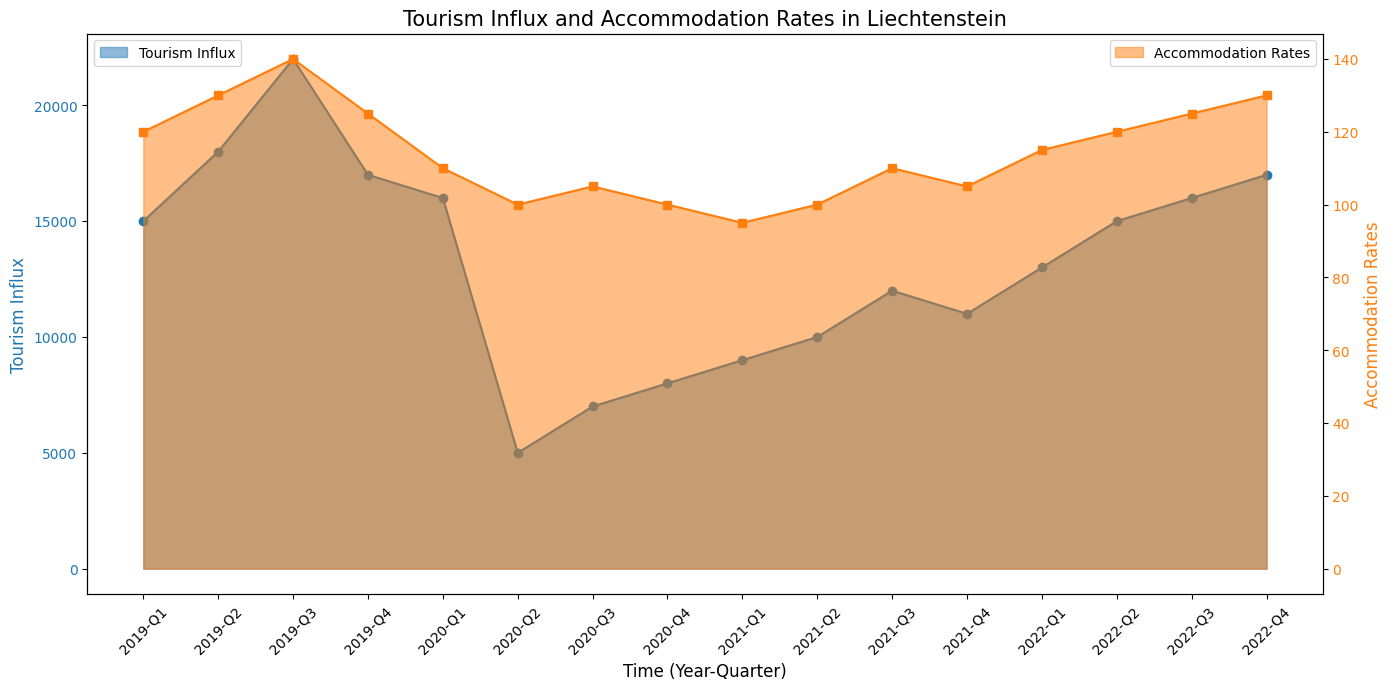What was the Tourism Influx in Q2 of 2020? First, locate the period Q2 of 2020 on the x-axis (Time). Then, look at the height of the blue area representing Tourism Influx. The value on the y-axis corresponding to Q2 2020 indicates that the value is 5000.
Answer: 5000 Which quarter had the highest Accommodation Rates in 2019? Identify the quarters of 2019 on the x-axis. Compare the heights of the orange areas (Accommodation Rates) for Q1, Q2, Q3, and Q4. Q3 2019 has the highest height of 140 on the right y-axis.
Answer: Q3 How much did the Tourism Influx drop from Q2 2019 to Q2 2020? Find the Tourism Influx values for Q2 2019 and Q2 2020. Q2 2019 has a value of 18000 and Q2 2020 has a value of 5000. Subtract the latter from the former: 18000 - 5000 = 13000.
Answer: 13000 What is the average Accommodation Rate for the year 2020? List the Accommodation Rates for the four quarters of 2020: 110, 100, 105, 100. Calculate the sum: 110 + 100 + 105 + 100 = 415. Divide by the number of quarters (4): 415 / 4 = 103.75.
Answer: 103.75 Which is greater, the Tourism Influx in Q1 2021 or Q1 2022? Locate Q1 2021 and Q1 2022 on the x-axis. Check the height of the blue areas for each quarter. Q1 2021 has a value of 9000 and Q1 2022 has a value of 13000. 13000 is greater than 9000.
Answer: Q1 2022 When were the Accommodation Rates the lowest? Inspect the orange areas to find the lowest point. The lowest Accommodation Rate is 95, which occurs in Q1 2021.
Answer: Q1 2021 What is the difference in Accommodation Rates between Q1 and Q4 of 2022? Find the Accommodation Rates for Q1 2022 and Q4 2022. Q1 2022 had 115, and Q4 2022 had 130. Calculate the difference: 130 - 115 = 15.
Answer: 15 What trend is observed in Tourism Influx from Q2 2020 to Q4 2022? Observe the blue area from Q2 2020 to Q4 2022. The value starts at 5000 in Q2 2020 and generally increases each quarter, reaching 17000 in Q4 2022. This indicates a rising trend.
Answer: Rising trend By how much did the Accommodation Rates change from Q3 2019 to Q3 2020? Find the Accommodation Rates for Q3 2019 and Q3 2020. Q3 2019 has a value of 140, and Q3 2020 has a value of 105. The change is 140 - 105 = 35.
Answer: 35 When did the Tourism Influx show a significant rise after the initial drop in 2020? After the initial drop in Q2 2020, look for a significant rise on the blue area. The influx significantly increases between Q3 2020 (7000) and Q1 2021 (9000), and continues rising in subsequent quarters.
Answer: Q1 2021 